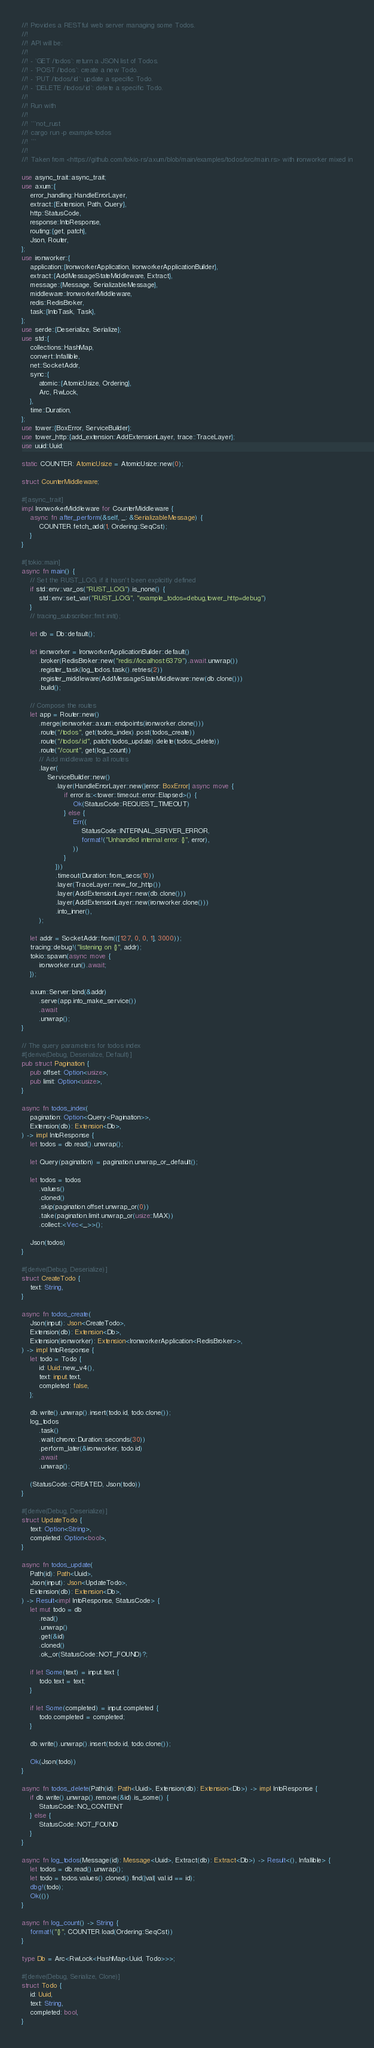Convert code to text. <code><loc_0><loc_0><loc_500><loc_500><_Rust_>//! Provides a RESTful web server managing some Todos.
//!
//! API will be:
//!
//! - `GET /todos`: return a JSON list of Todos.
//! - `POST /todos`: create a new Todo.
//! - `PUT /todos/:id`: update a specific Todo.
//! - `DELETE /todos/:id`: delete a specific Todo.
//!
//! Run with
//!
//! ```not_rust
//! cargo run -p example-todos
//! ```
//!
//! Taken from <https://github.com/tokio-rs/axum/blob/main/examples/todos/src/main.rs> with ironworker mixed in

use async_trait::async_trait;
use axum::{
    error_handling::HandleErrorLayer,
    extract::{Extension, Path, Query},
    http::StatusCode,
    response::IntoResponse,
    routing::{get, patch},
    Json, Router,
};
use ironworker::{
    application::{IronworkerApplication, IronworkerApplicationBuilder},
    extract::{AddMessageStateMiddleware, Extract},
    message::{Message, SerializableMessage},
    middleware::IronworkerMiddleware,
    redis::RedisBroker,
    task::{IntoTask, Task},
};
use serde::{Deserialize, Serialize};
use std::{
    collections::HashMap,
    convert::Infallible,
    net::SocketAddr,
    sync::{
        atomic::{AtomicUsize, Ordering},
        Arc, RwLock,
    },
    time::Duration,
};
use tower::{BoxError, ServiceBuilder};
use tower_http::{add_extension::AddExtensionLayer, trace::TraceLayer};
use uuid::Uuid;

static COUNTER: AtomicUsize = AtomicUsize::new(0);

struct CounterMiddleware;

#[async_trait]
impl IronworkerMiddleware for CounterMiddleware {
    async fn after_perform(&self, _: &SerializableMessage) {
        COUNTER.fetch_add(1, Ordering::SeqCst);
    }
}

#[tokio::main]
async fn main() {
    // Set the RUST_LOG, if it hasn't been explicitly defined
    if std::env::var_os("RUST_LOG").is_none() {
        std::env::set_var("RUST_LOG", "example_todos=debug,tower_http=debug")
    }
    // tracing_subscriber::fmt::init();

    let db = Db::default();

    let ironworker = IronworkerApplicationBuilder::default()
        .broker(RedisBroker::new("redis://localhost:6379").await.unwrap())
        .register_task(log_todos.task().retries(2))
        .register_middleware(AddMessageStateMiddleware::new(db.clone()))
        .build();

    // Compose the routes
    let app = Router::new()
        .merge(ironworker::axum::endpoints(ironworker.clone()))
        .route("/todos", get(todos_index).post(todos_create))
        .route("/todos/:id", patch(todos_update).delete(todos_delete))
        .route("/count", get(log_count))
        // Add middleware to all routes
        .layer(
            ServiceBuilder::new()
                .layer(HandleErrorLayer::new(|error: BoxError| async move {
                    if error.is::<tower::timeout::error::Elapsed>() {
                        Ok(StatusCode::REQUEST_TIMEOUT)
                    } else {
                        Err((
                            StatusCode::INTERNAL_SERVER_ERROR,
                            format!("Unhandled internal error: {}", error),
                        ))
                    }
                }))
                .timeout(Duration::from_secs(10))
                .layer(TraceLayer::new_for_http())
                .layer(AddExtensionLayer::new(db.clone()))
                .layer(AddExtensionLayer::new(ironworker.clone()))
                .into_inner(),
        );

    let addr = SocketAddr::from(([127, 0, 0, 1], 3000));
    tracing::debug!("listening on {}", addr);
    tokio::spawn(async move {
        ironworker.run().await;
    });

    axum::Server::bind(&addr)
        .serve(app.into_make_service())
        .await
        .unwrap();
}

// The query parameters for todos index
#[derive(Debug, Deserialize, Default)]
pub struct Pagination {
    pub offset: Option<usize>,
    pub limit: Option<usize>,
}

async fn todos_index(
    pagination: Option<Query<Pagination>>,
    Extension(db): Extension<Db>,
) -> impl IntoResponse {
    let todos = db.read().unwrap();

    let Query(pagination) = pagination.unwrap_or_default();

    let todos = todos
        .values()
        .cloned()
        .skip(pagination.offset.unwrap_or(0))
        .take(pagination.limit.unwrap_or(usize::MAX))
        .collect::<Vec<_>>();

    Json(todos)
}

#[derive(Debug, Deserialize)]
struct CreateTodo {
    text: String,
}

async fn todos_create(
    Json(input): Json<CreateTodo>,
    Extension(db): Extension<Db>,
    Extension(ironworker): Extension<IronworkerApplication<RedisBroker>>,
) -> impl IntoResponse {
    let todo = Todo {
        id: Uuid::new_v4(),
        text: input.text,
        completed: false,
    };

    db.write().unwrap().insert(todo.id, todo.clone());
    log_todos
        .task()
        .wait(chrono::Duration::seconds(30))
        .perform_later(&ironworker, todo.id)
        .await
        .unwrap();

    (StatusCode::CREATED, Json(todo))
}

#[derive(Debug, Deserialize)]
struct UpdateTodo {
    text: Option<String>,
    completed: Option<bool>,
}

async fn todos_update(
    Path(id): Path<Uuid>,
    Json(input): Json<UpdateTodo>,
    Extension(db): Extension<Db>,
) -> Result<impl IntoResponse, StatusCode> {
    let mut todo = db
        .read()
        .unwrap()
        .get(&id)
        .cloned()
        .ok_or(StatusCode::NOT_FOUND)?;

    if let Some(text) = input.text {
        todo.text = text;
    }

    if let Some(completed) = input.completed {
        todo.completed = completed;
    }

    db.write().unwrap().insert(todo.id, todo.clone());

    Ok(Json(todo))
}

async fn todos_delete(Path(id): Path<Uuid>, Extension(db): Extension<Db>) -> impl IntoResponse {
    if db.write().unwrap().remove(&id).is_some() {
        StatusCode::NO_CONTENT
    } else {
        StatusCode::NOT_FOUND
    }
}

async fn log_todos(Message(id): Message<Uuid>, Extract(db): Extract<Db>) -> Result<(), Infallible> {
    let todos = db.read().unwrap();
    let todo = todos.values().cloned().find(|val| val.id == id);
    dbg!(todo);
    Ok(())
}

async fn log_count() -> String {
    format!("{}", COUNTER.load(Ordering::SeqCst))
}

type Db = Arc<RwLock<HashMap<Uuid, Todo>>>;

#[derive(Debug, Serialize, Clone)]
struct Todo {
    id: Uuid,
    text: String,
    completed: bool,
}
</code> 